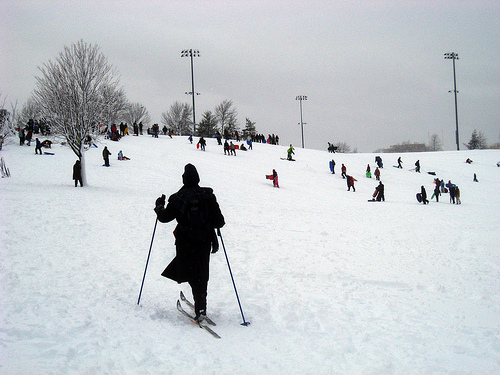Please provide a short description for this region: [0.83, 0.49, 0.86, 0.54]. A skier positioned on the snowy mountain, with the expansive white landscape surrounding them. 